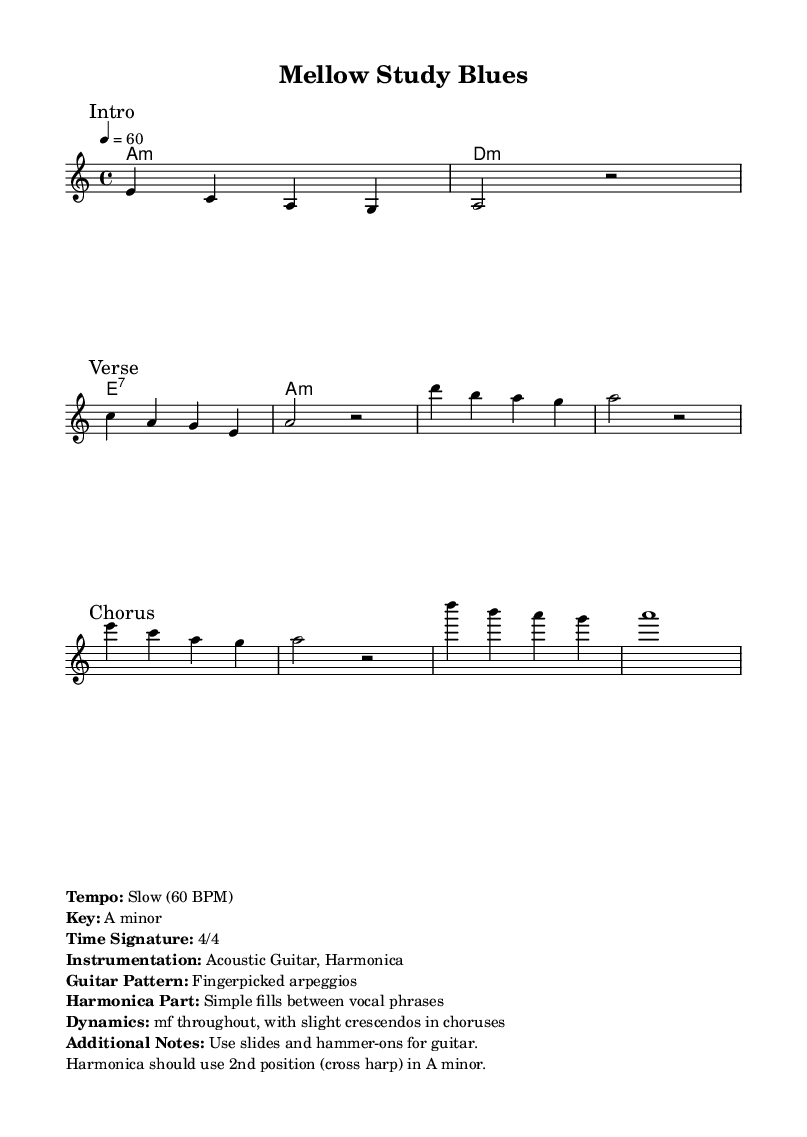What is the key signature of this music? The key signature is A minor, which typically has no sharps or flats, and this is indicated at the beginning of the sheet.
Answer: A minor What is the time signature of this music? The time signature is found in the first measure and shows how many beats are in each measure. This is specified as 4/4, meaning four beats per measure.
Answer: 4/4 What is the tempo marking for this piece? The tempo indicates the speed of the music and is marked at the beginning. It specifies a slow tempo of 60 beats per minute here.
Answer: Slow (60 BPM) Which instrument is indicated as playing the melody? The melody is assigned to a voice part, and it is clear from the score layout that it is written for one specific instrument which is an acoustic guitar.
Answer: Acoustic Guitar How many measures are in the Chorus section? To find the number of measures in the Chorus, one can count the measures delineated in the section. In this case, there are four measures indicated for the Chorus.
Answer: 4 What dynamic level is marked throughout the piece? The dynamics are indicated in the additional notes, where it is stated that the dynamic is marked as mezzo-forte, which means moderately loud, for the entire piece.
Answer: mf What specific technique is suggested for the guitar part? The additional notes specify techniques for playing the guitar part. This includes using slides and hammer-ons, which are types of finger techniques.
Answer: Slides and hammer-ons 